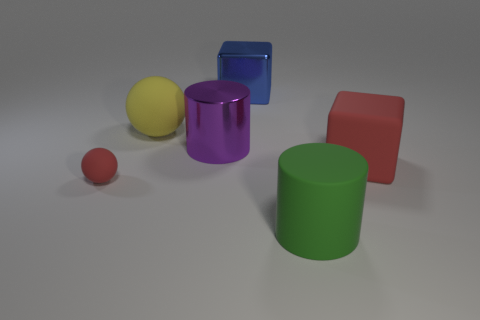Is there anything else that has the same material as the large purple cylinder?
Provide a succinct answer. Yes. There is a block that is the same color as the small sphere; what is it made of?
Provide a succinct answer. Rubber. Is the number of yellow rubber objects to the right of the big matte cube the same as the number of tiny purple spheres?
Offer a very short reply. Yes. There is a red rubber sphere; are there any shiny cubes to the left of it?
Ensure brevity in your answer.  No. There is a small matte object; does it have the same shape as the large rubber thing that is to the left of the blue block?
Offer a terse response. Yes. The other large thing that is made of the same material as the blue thing is what color?
Your answer should be compact. Purple. What color is the rubber cube?
Your answer should be compact. Red. Is the large yellow thing made of the same material as the cylinder that is behind the tiny matte object?
Your answer should be compact. No. What number of matte things are both to the left of the large blue object and in front of the large shiny cylinder?
Provide a short and direct response. 1. There is a blue thing that is the same size as the yellow sphere; what shape is it?
Offer a terse response. Cube. 